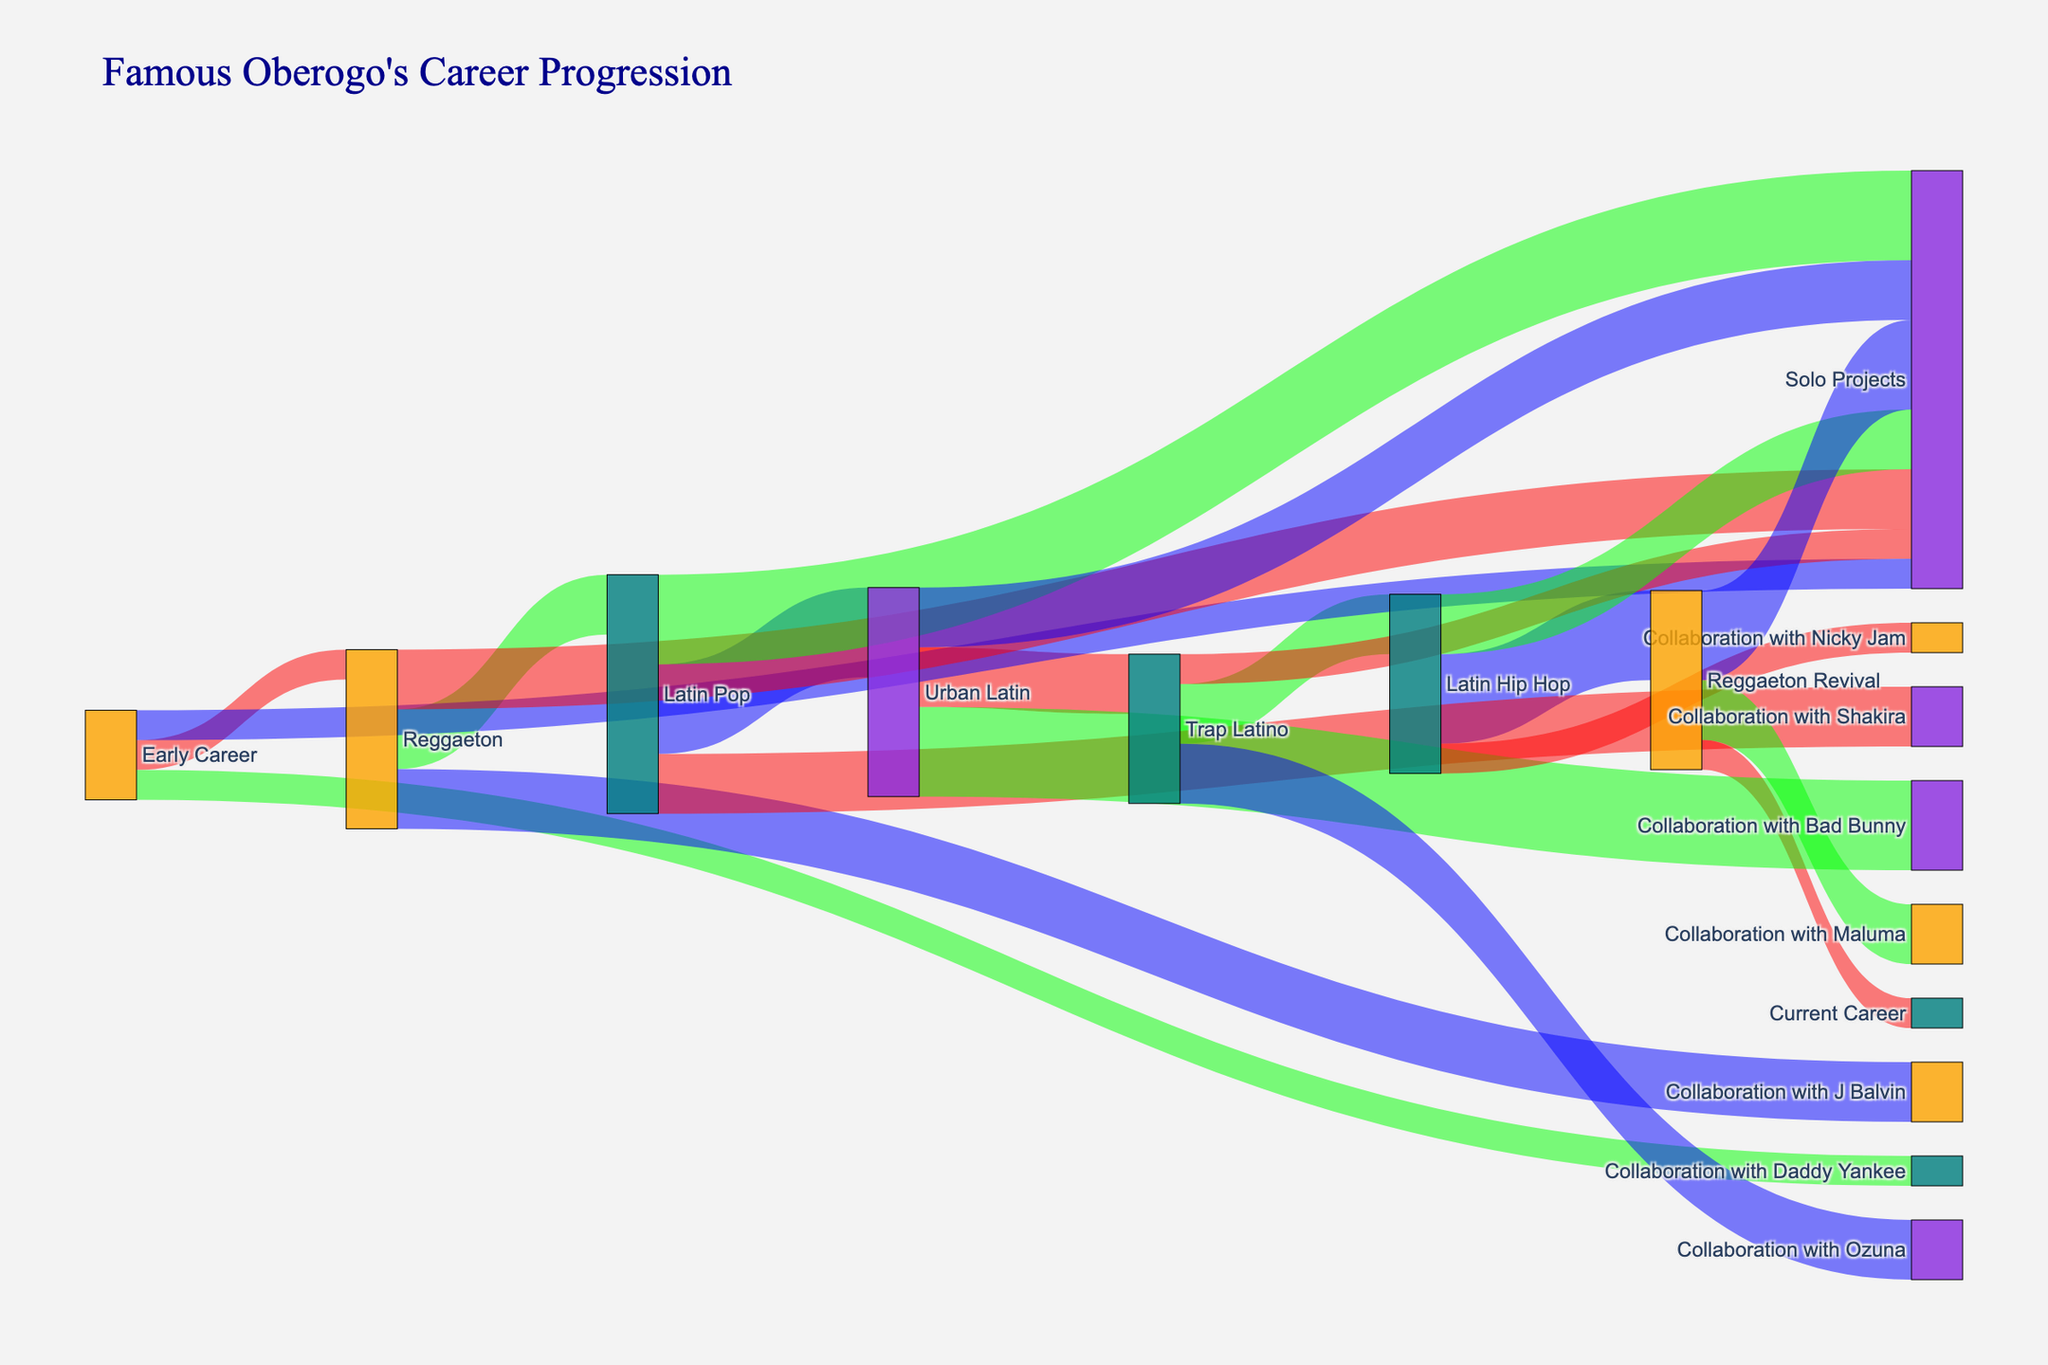¿En qué género musical comenzó Famous Oberogo su carrera? Mirando la figura, vemos que el nodo "Early Career" está conectado con el nodo "Reggaeton", lo que indica que comenzó su carrera en ese género.
Answer: Reggaeton ¿Cuántos géneros musicales se mencionan en la figura por donde ha pasado Famous Oberogo? Observando los nodos relacionados con los géneros musicales en la figura, podemos contar "Reggaeton", "Latin Pop", "Urban Latin", "Trap Latino", "Latin Hip Hop", y "Reggaeton Revival", haciendo un total de seis géneros.
Answer: Seis ¿Cuál es el género musical con más conexiones a otros nodos? Al contar las conexiones de cada nodo que representa un género musical, el nodo "Latin Hip Hop" y "Reggaeton Revival" tienen la mayor cantidad de conexiones (3 cada uno).
Answer: Latin Hip Hop y Reggaeton Revival ¿Qué nodo está directamente conectado a "Collaboration with Daddy Yankee"? La figura muestra que el nodo "Early Career" está conectado a "Collaboration with Daddy Yankee".
Answer: Early Career ¿Cuántas colaboraciones con otros artistas se muestran en la figura? Contando los enlaces que van desde los géneros (o "Early Career") a colaboraciones, encontramos siete colaboraciones: "Collaboration with Daddy Yankee", "Collaboration with J Balvin", "Collaboration with Shakira", "Collaboration with Bad Bunny", "Collaboration with Ozuna", "Collaboration with Nicky Jam", y "Collaboration with Maluma".
Answer: Siete ¿Cuántos enlaces se dirigen hacia el nodo "Solo Projects"? Contando los enlaces hacia el nodo "Solo Projects" desde los géneros y "Early Career", encontramos siete: uno desde "Early Career", dos desde "Reggaeton", tres desde "Latin Pop", dos desde "Urban Latin", uno desde "Trap Latino", dos desde "Latin Hip Hop", y tres desde "Reggaeton Revival".
Answer: Siete ¿Cuáles son las dos colaboraciones relacionadas con el género "Trap Latino"? Observando los enlaces desde el nodo "Trap Latino", vemos que están "Collaboration with Ozuna" y "Solo Projects".
Answer: Collaboration with Ozuna y Solo Projects ¿Qué nodos están involucrados en la transición más compleja en términos de número de pasos en la carrera de Famous Oberogo? La transición de "Early Career" a "Current Career" pasa por varios nodos: "Early Career" -> "Reggaeton" -> "Latin Pop" -> "Urban Latin" -> "Trap Latino" -> "Latin Hip Hop" -> "Reggaeton Revival" -> "Current Career".
Answer: Early Career a Current Career 